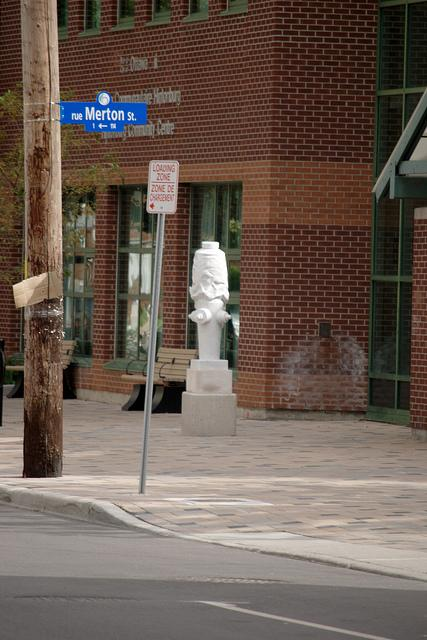The sculpture in front of the building is modeled after what common object found on a sidewalk? fire hydrant 